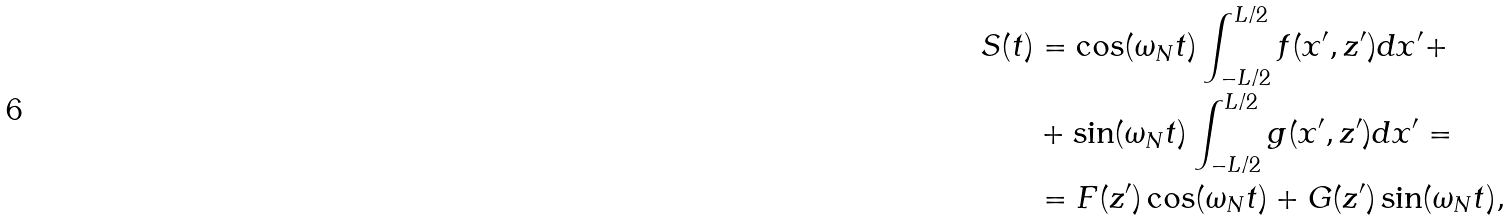<formula> <loc_0><loc_0><loc_500><loc_500>S ( t ) & = \cos ( \omega _ { N } t ) \int _ { - L / 2 } ^ { L / 2 } f ( x ^ { \prime } , z ^ { \prime } ) d x ^ { \prime } + \\ & + \sin ( \omega _ { N } t ) \int _ { - L / 2 } ^ { L / 2 } g ( x ^ { \prime } , z ^ { \prime } ) d x ^ { \prime } = \\ & = F ( z ^ { \prime } ) \cos ( \omega _ { N } t ) + G ( z ^ { \prime } ) \sin ( \omega _ { N } t ) ,</formula> 